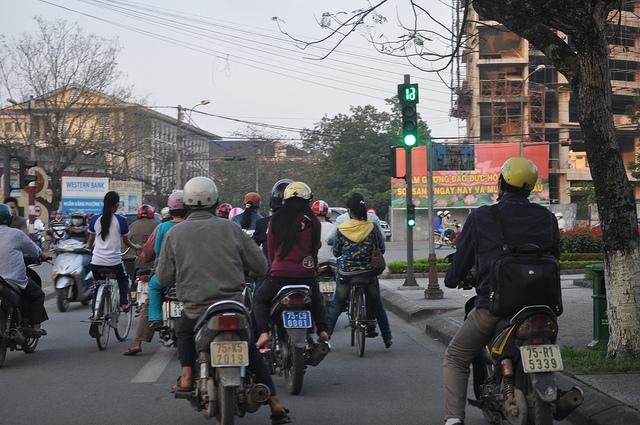What color are the numbers on the top of the pole with the traffic lights? green 